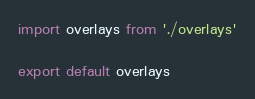Convert code to text. <code><loc_0><loc_0><loc_500><loc_500><_JavaScript_>import overlays from './overlays'

export default overlays
</code> 